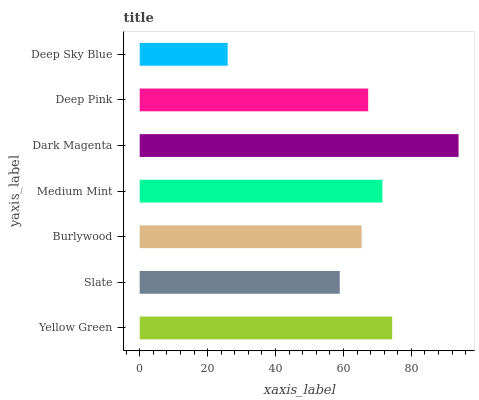Is Deep Sky Blue the minimum?
Answer yes or no. Yes. Is Dark Magenta the maximum?
Answer yes or no. Yes. Is Slate the minimum?
Answer yes or no. No. Is Slate the maximum?
Answer yes or no. No. Is Yellow Green greater than Slate?
Answer yes or no. Yes. Is Slate less than Yellow Green?
Answer yes or no. Yes. Is Slate greater than Yellow Green?
Answer yes or no. No. Is Yellow Green less than Slate?
Answer yes or no. No. Is Deep Pink the high median?
Answer yes or no. Yes. Is Deep Pink the low median?
Answer yes or no. Yes. Is Slate the high median?
Answer yes or no. No. Is Yellow Green the low median?
Answer yes or no. No. 